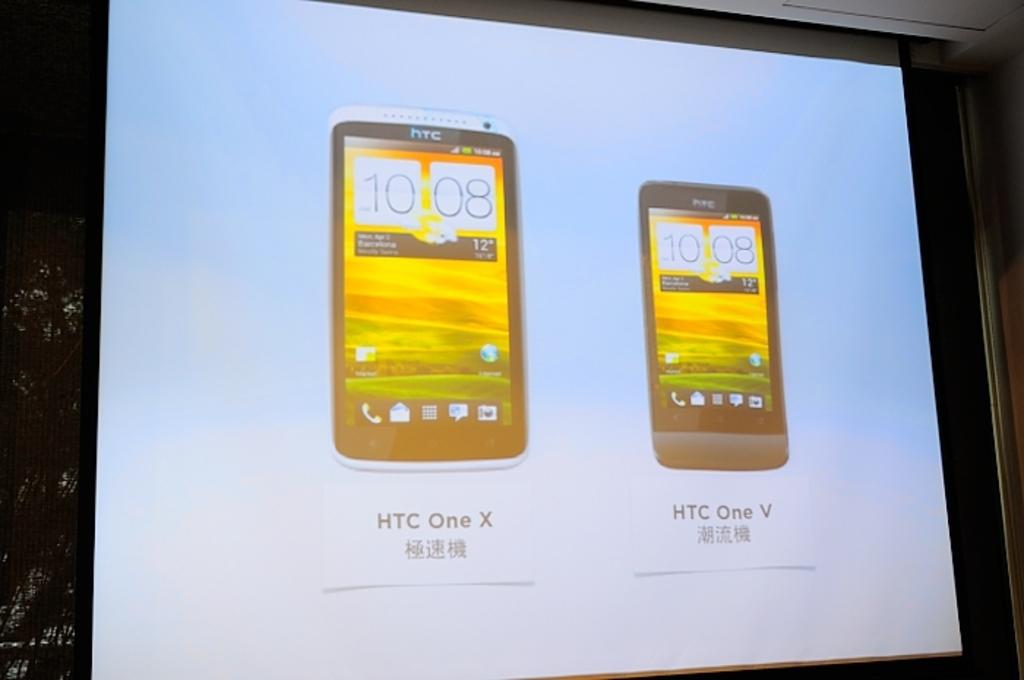<image>
Render a clear and concise summary of the photo. Two cell phones from HTC displayed on a projector screen. 